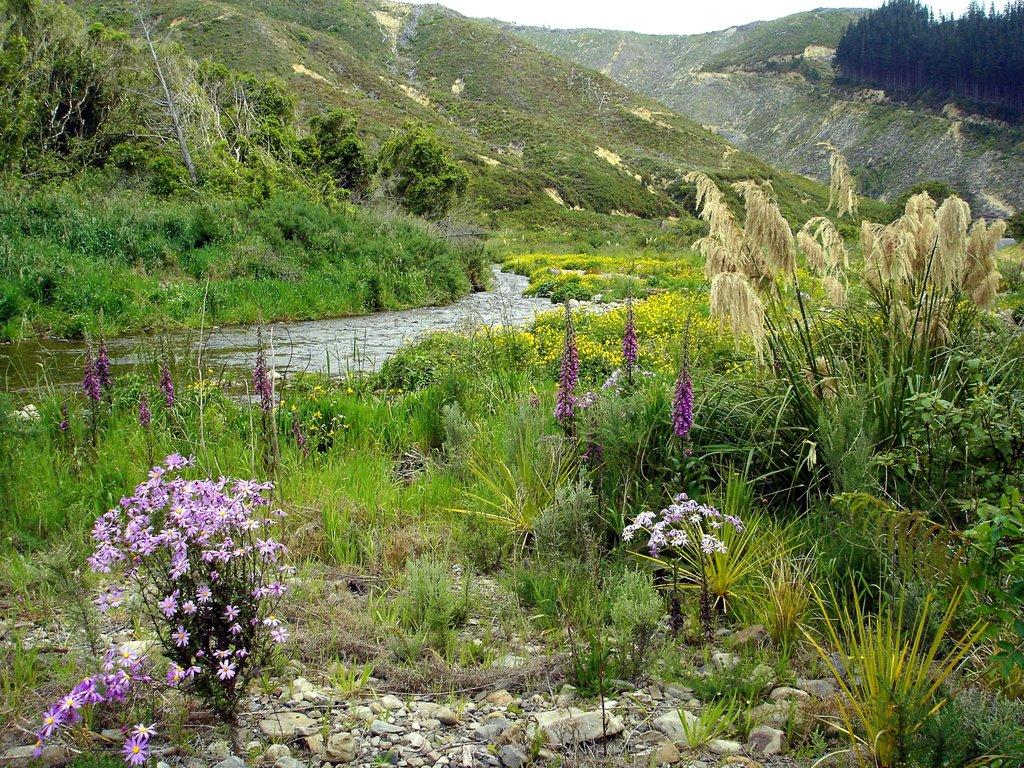What type of terrain is visible in the image? There is an open grass ground in the image. What can be seen in the front of the image? There are flowers in the front of the image. What is located in the center of the image? There is water in the center of the image. What is visible in the background of the image? There are trees in the background of the image. What is the income of the flowers in the image? The image does not provide information about the income of the flowers, as flowers do not have an income. 